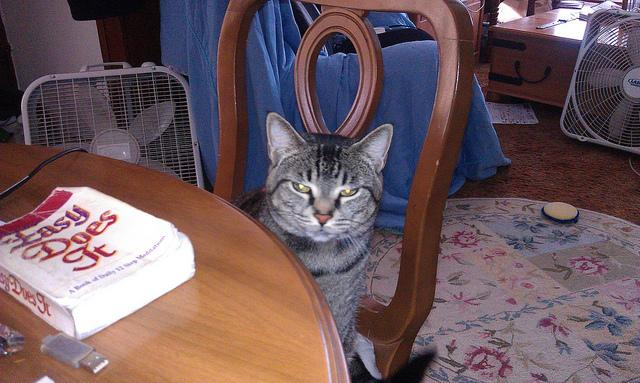The cat is sitting at a table with what featured on top of it?

Choices:
A) plate
B) fan
C) knife
D) book book 